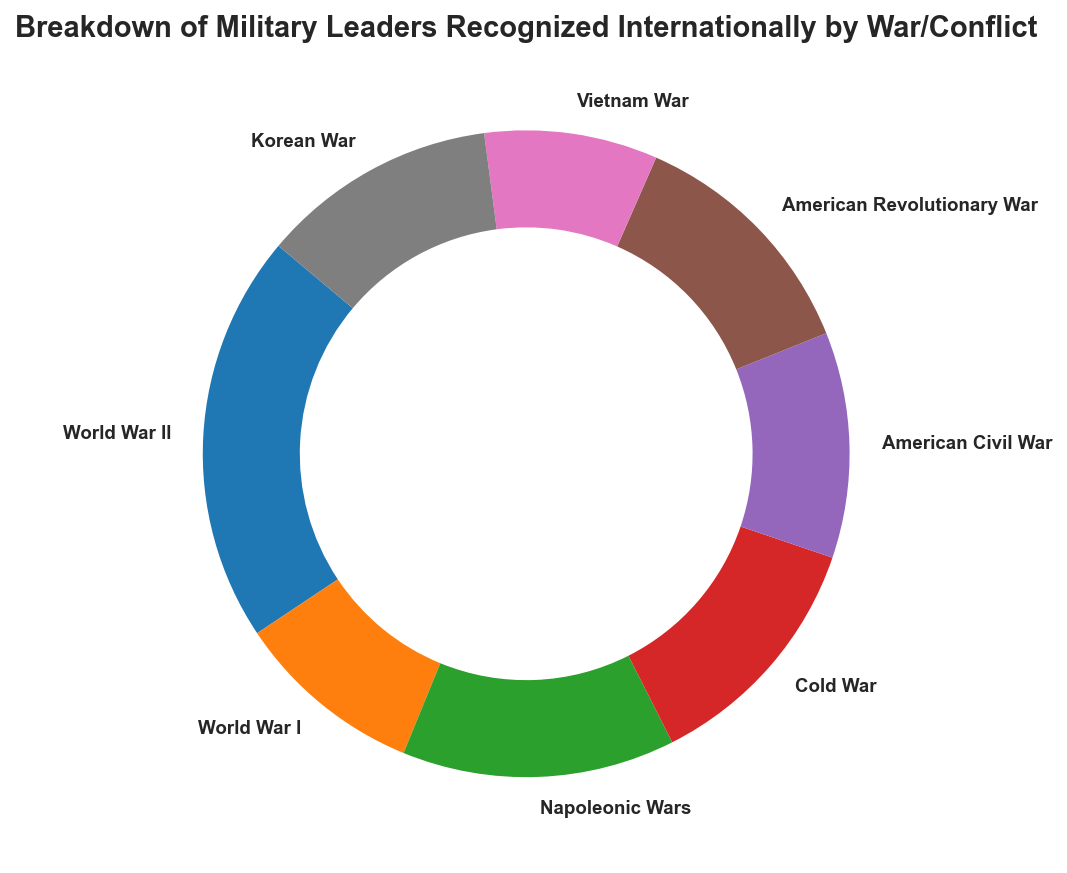What's the most recognized war/conflict? To determine the most recognized war/conflict, look at the percentages on the ring chart and identify the segment with the largest percentage.
Answer: Napoleonic Wars Which war/conflict has the smallest recognition count? To find the war/conflict with the smallest recognition count, identify the segment with the smallest percentage on the ring chart.
Answer: Vietnam War How does the recognition count of World War II compare to World War I? To compare World War II and World War I, note the percentages of both conflicts on the ring chart. Calculate the approximate counts based on the total count and compare. For World War II, the recognition count is the sum of (25 + 20 + 18 + 15) = 78. For World War I, it is (12 + 10 + 8 + 6) = 36.
Answer: World War II has a higher recognition count What is the total number of recognitions for leaders from the American Civil War? To find the total recognitions for the American Civil War, sum the individual counts: (18 + 15 + 10) = 43.
Answer: 43 Which conflict accounts for the highest percentage of recognized military leaders? Identify the largest segment on the ring chart and check its associated war/conflict. The Napoleonic Wars segment is the largest.
Answer: Napoleonic Wars How many conflicts have a recognition count greater than 40? Count all the conflicts where the segment's percentage suggests a recognition count greater than 40. The total recognition count on the chart is 324, so segments representing more than around 12% of the chart have counts greater than 40. There are two such segments – Napoleonic Wars and World War II.
Answer: 2 If we add the recognition counts of World War I and the Korean War, does their total surpass the recognition count of the Cold War? Calculate the total for World War I (36) and the Korean War (45) and compare it with the recognition count of the Cold War (47). The combined total of World War I and Korean War is 81, which is greater than 47.
Answer: Yes Which war has higher recognition, the American Revolutionary War or the American Civil War? Compare the percentages of the American Revolutionary War and the American Civil War from the ring chart. The recognition count for the American Revolutionary War is 47, while for the American Civil War it is 43.
Answer: American Revolutionary War What is the average recognition count per leader for the Cold War? To calculate the average recognition count per leader for the Cold War, sum the counts (20 + 15 + 12) = 47, and divide by the number of leaders (3). This gives an average of 47/3 ≈ 15.67.
Answer: 15.67 Compare the visual sizes of the segments representing the Napoleonic Wars and World War II. Which one is larger? Visually inspect the chart and compare the sizes of the segments for Napoleonic Wars and World War II. The Napoleonic Wars segment is larger.
Answer: Napoleonic Wars 